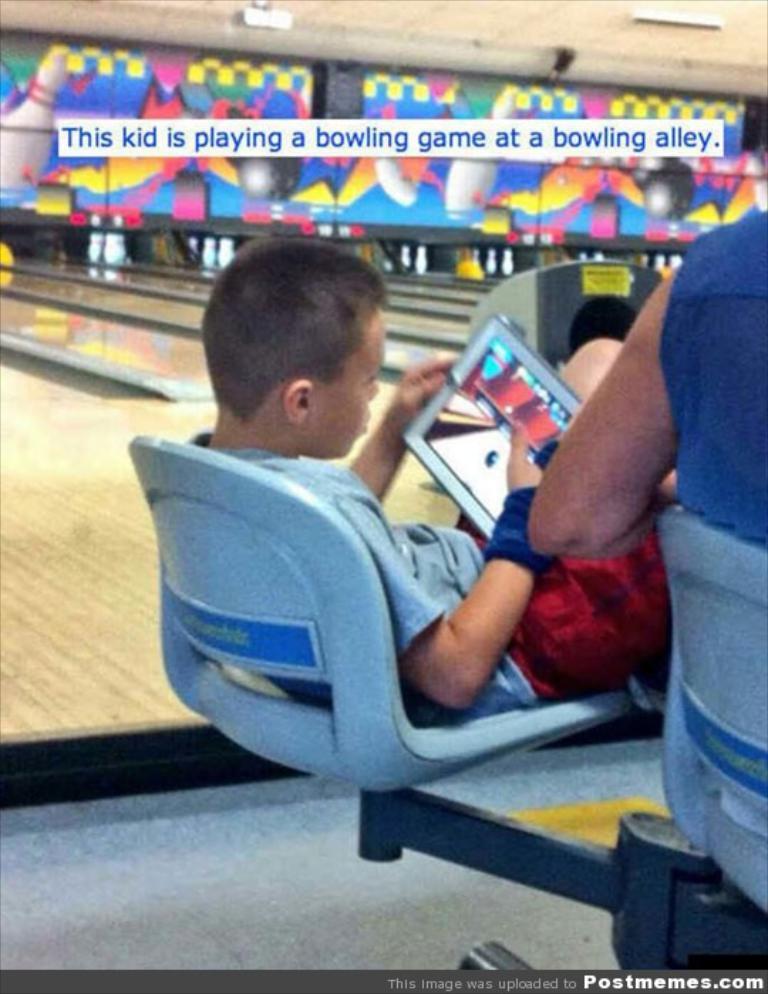What does the caption say about the kid?
Your answer should be very brief. This kid is playing a bowling game at a bowling alley. What website is at the bottom right?
Your answer should be compact. Postmemes.com. 